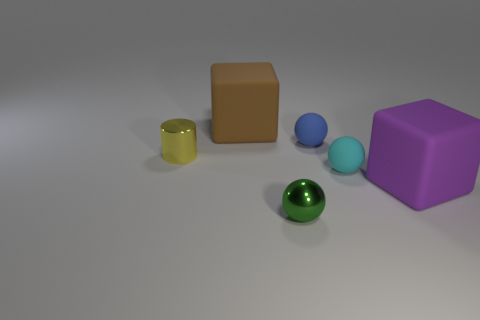Subtract 1 balls. How many balls are left? 2 Subtract all rubber balls. How many balls are left? 1 Add 2 tiny metal cubes. How many objects exist? 8 Subtract all large rubber cubes. Subtract all tiny green spheres. How many objects are left? 3 Add 3 small metallic things. How many small metallic things are left? 5 Add 3 big matte cylinders. How many big matte cylinders exist? 3 Subtract 0 brown cylinders. How many objects are left? 6 Subtract all cylinders. How many objects are left? 5 